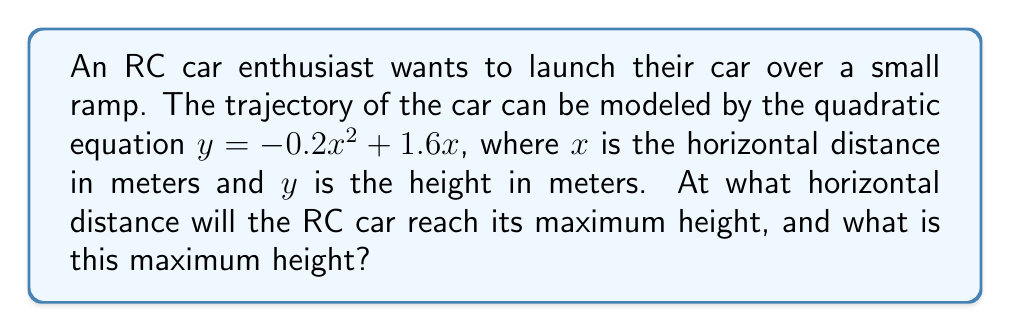Can you solve this math problem? Let's approach this step-by-step:

1) The quadratic equation given is $y = -0.2x^2 + 1.6x$

2) To find the maximum height, we need to find the vertex of this parabola. The x-coordinate of the vertex will give us the horizontal distance at which the maximum height is reached.

3) For a quadratic equation in the form $y = ax^2 + bx + c$, the x-coordinate of the vertex is given by $x = -\frac{b}{2a}$

4) In our equation, $a = -0.2$ and $b = 1.6$

5) Substituting these values:

   $x = -\frac{1.6}{2(-0.2)} = -\frac{1.6}{-0.4} = 4$

6) So, the RC car will reach its maximum height at a horizontal distance of 4 meters.

7) To find the maximum height, we substitute $x = 4$ into our original equation:

   $y = -0.2(4)^2 + 1.6(4)$
   $y = -0.2(16) + 6.4$
   $y = -3.2 + 6.4 = 3.2$

8) Therefore, the maximum height reached is 3.2 meters.
Answer: 4 meters horizontally, 3.2 meters high 